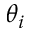Convert formula to latex. <formula><loc_0><loc_0><loc_500><loc_500>\theta _ { i }</formula> 